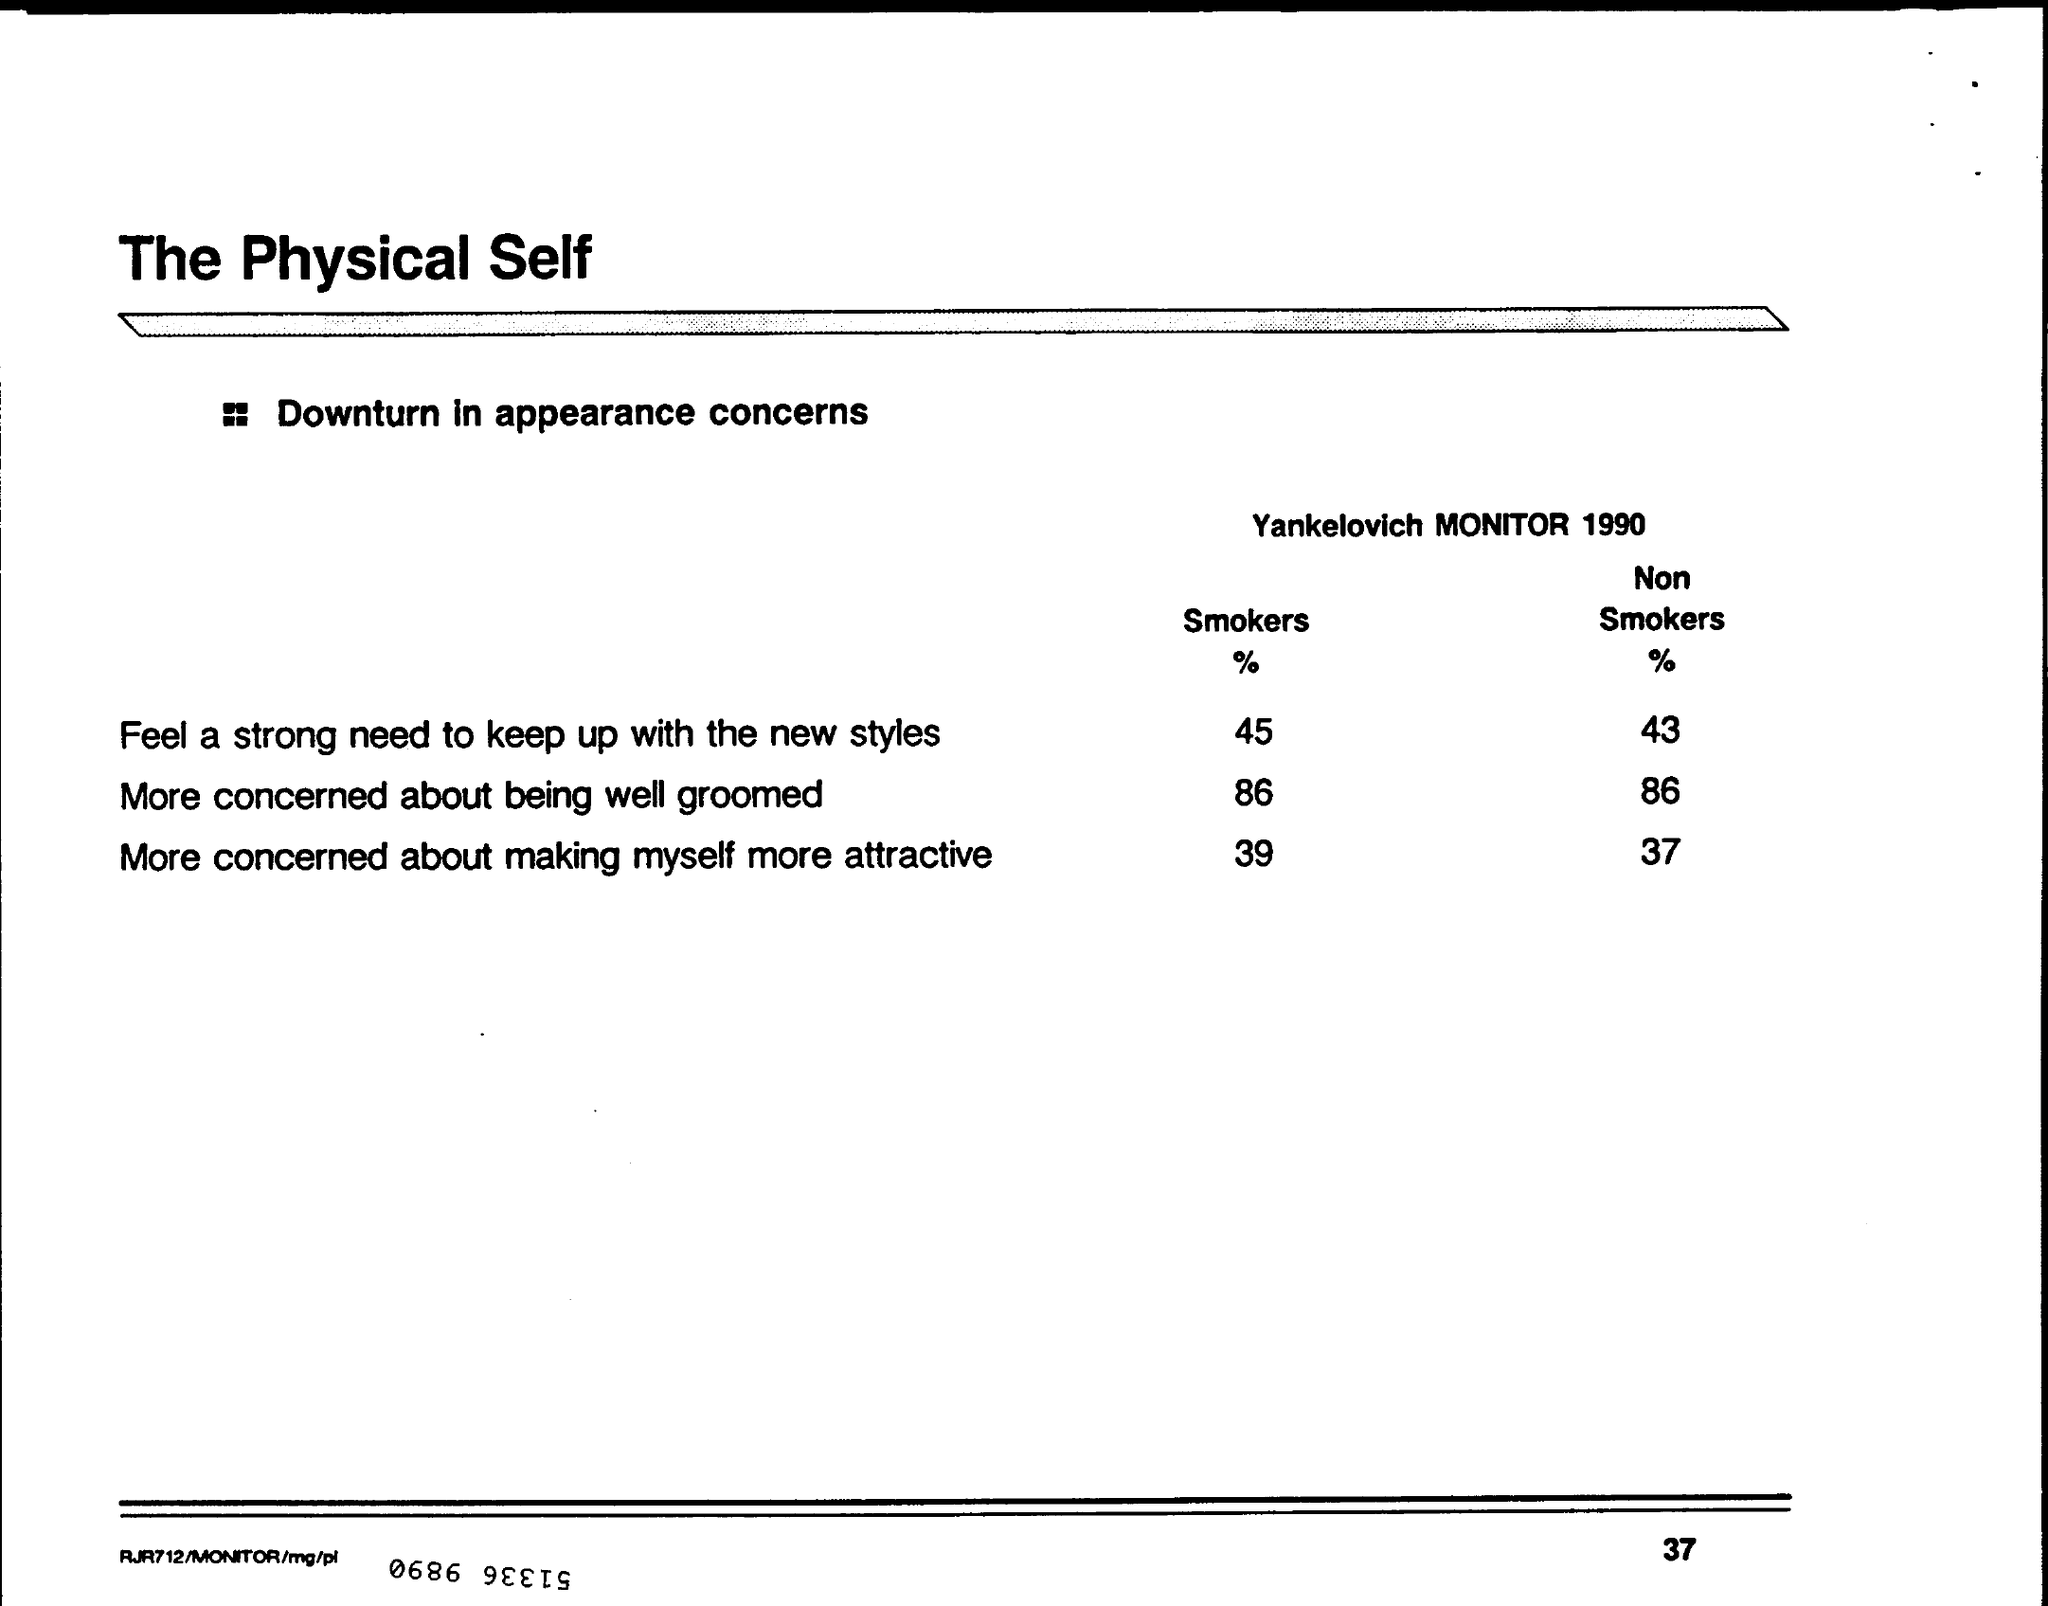Highlight a few significant elements in this photo. According to the data, 45% of smokers feel a strong desire to keep up with new styles. 